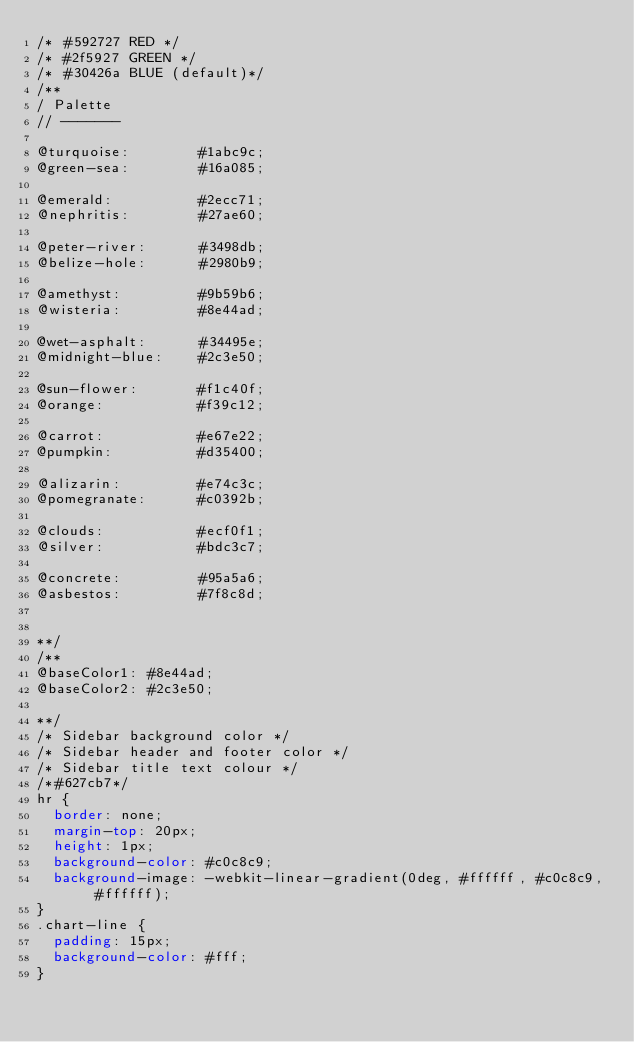<code> <loc_0><loc_0><loc_500><loc_500><_CSS_>/* #592727 RED */
/* #2f5927 GREEN */
/* #30426a BLUE (default)*/
/** 
/ Palette
// -------

@turquoise:        #1abc9c;
@green-sea:        #16a085;

@emerald:          #2ecc71;
@nephritis:        #27ae60;

@peter-river:      #3498db;
@belize-hole:      #2980b9;

@amethyst:         #9b59b6;
@wisteria:         #8e44ad;

@wet-asphalt:      #34495e;
@midnight-blue:    #2c3e50;

@sun-flower:       #f1c40f;
@orange:           #f39c12;

@carrot:           #e67e22;
@pumpkin:          #d35400;

@alizarin:         #e74c3c;
@pomegranate:      #c0392b;

@clouds:           #ecf0f1;
@silver:           #bdc3c7;

@concrete:         #95a5a6;
@asbestos:         #7f8c8d;


**/
/**
@baseColor1: #8e44ad;
@baseColor2: #2c3e50;

**/
/* Sidebar background color */
/* Sidebar header and footer color */
/* Sidebar title text colour */
/*#627cb7*/
hr {
  border: none;
  margin-top: 20px;
  height: 1px;
  background-color: #c0c8c9;
  background-image: -webkit-linear-gradient(0deg, #ffffff, #c0c8c9, #ffffff);
}
.chart-line {
  padding: 15px;
  background-color: #fff;
}
</code> 